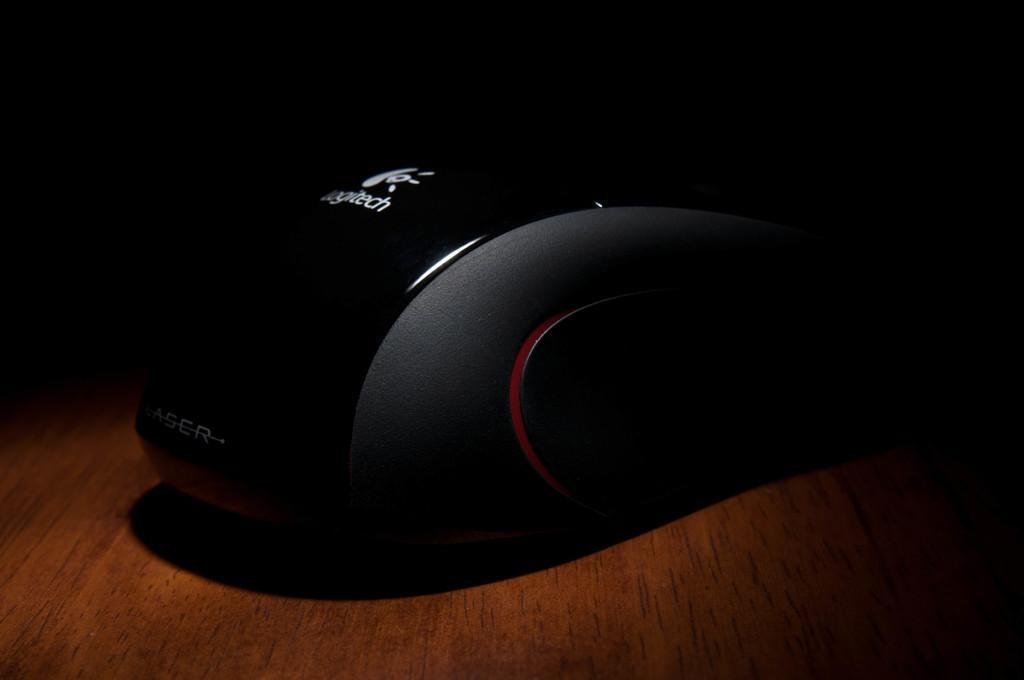Please provide a concise description of this image. This image is taken indoors. At the bottom of the image there is a table. In this image the background is dark. In the middle of the image there is a mouse on the table. 